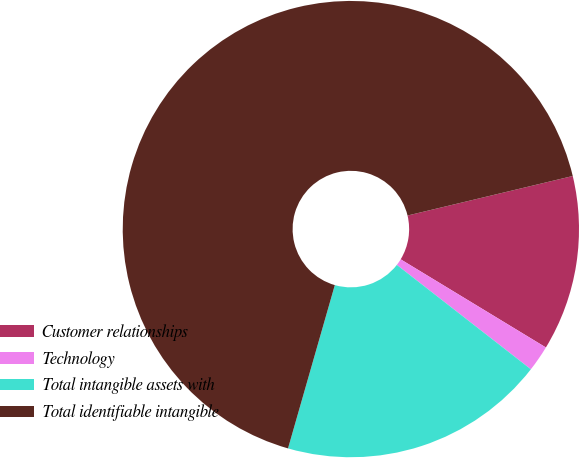Convert chart. <chart><loc_0><loc_0><loc_500><loc_500><pie_chart><fcel>Customer relationships<fcel>Technology<fcel>Total intangible assets with<fcel>Total identifiable intangible<nl><fcel>12.42%<fcel>1.85%<fcel>18.91%<fcel>66.82%<nl></chart> 